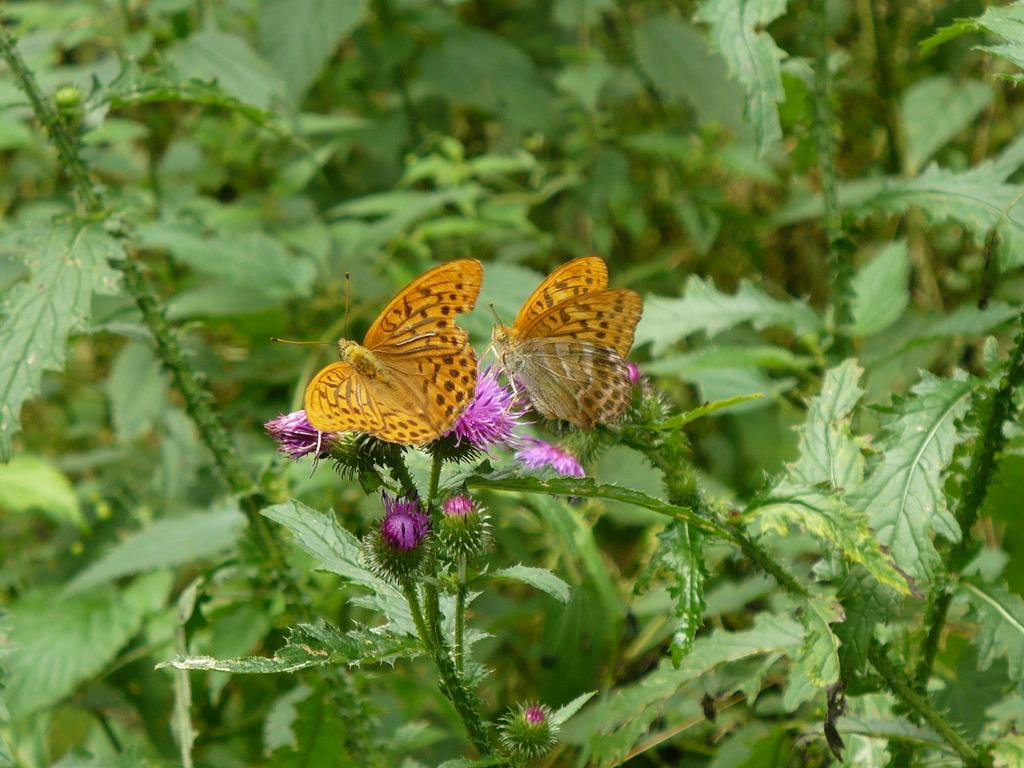What type of animals can be seen in the image? There are butterflies in the image. Where are the butterflies located in the image? The butterflies are sitting on flowers. What can be seen in the background of the image? There are plants in the background of the image. How many children are holding onto the butterflies in the image? There are no children present in the image, and the butterflies are sitting on flowers, not being held by anyone. What type of grip do the butterflies have on the flowers in the image? Butterflies do not have hands or a grip; they use their legs and feet to perch on flowers. 